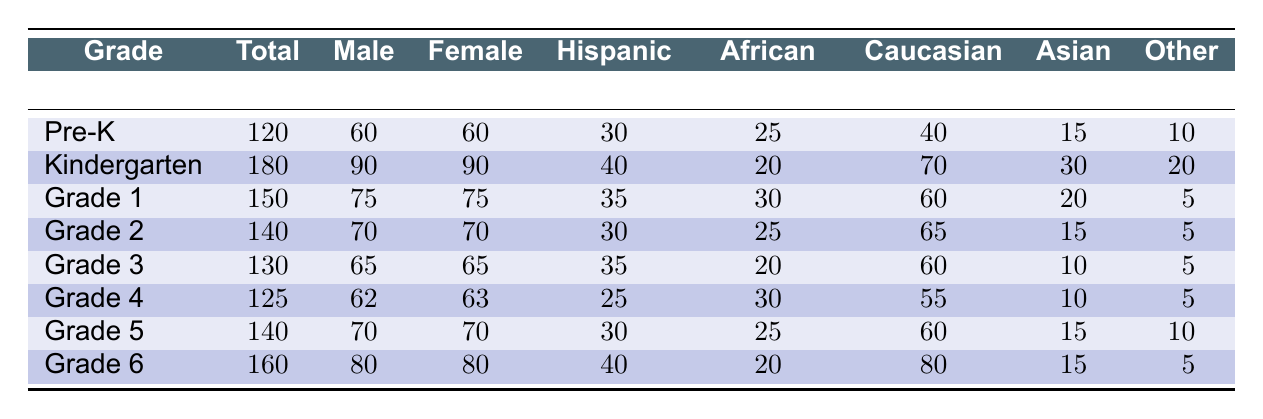What is the total enrollment in kindergarten? The table shows an entry for kindergarten under "Total," which is explicitly stated as 180.
Answer: 180 How many male students are in grade 5? Referring to the "Male" column for grade 5, the table indicates there are 70 male students.
Answer: 70 Is the number of female students in grade 2 greater than those in pre-kindergarten? Female students in grade 2 total 70, while in pre-kindergarten there are also 60 female students. Since 70 is greater than 60, the statement is true.
Answer: Yes What is the difference in total enrollment between grade 1 and grade 4? Total enrollment for grade 1 is 150, and for grade 4 it is 125. The difference can be calculated by subtracting the total enrollment of grade 4 from grade 1: 150 - 125 = 25.
Answer: 25 Which grade has the highest number of Hispanic students and how many? Looking at the "Hispanic" column across all grades, grade 6 has the highest number with 40 Hispanic students.
Answer: Grade 6, 40 What is the average number of female students across grades 3, 4, and 5? The number of female students in grades 3, 4, and 5 are 65, 63, and 70, respectively. First, calculate the total: 65 + 63 + 70 = 198. Then, divide by 3 to find the average: 198 / 3 = 66.
Answer: 66 Are there more Caucasian students in kindergarten or grade 6? Kindergarten has 70 Caucasian students, while grade 6 has 80. Since 80 is greater than 70, the statement is true.
Answer: No What is the total enrollment for all grades combined? Adding the total enrollments of all grades: 120 + 180 + 150 + 140 + 130 + 125 + 140 + 160 = 1095.
Answer: 1095 Which grade has the fewest female students and how many? Reviewing the "Female" column, grade 4 has the fewest female students with a total of 63.
Answer: Grade 4, 63 